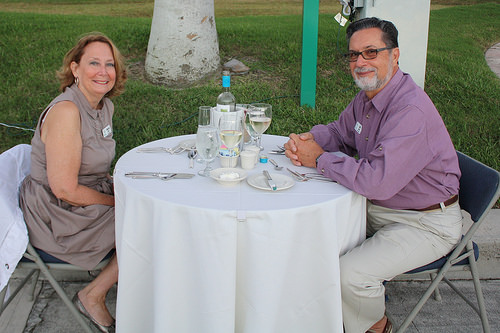<image>
Can you confirm if the glass is to the right of the person? Yes. From this viewpoint, the glass is positioned to the right side relative to the person. Is the man next to the table? Yes. The man is positioned adjacent to the table, located nearby in the same general area. 